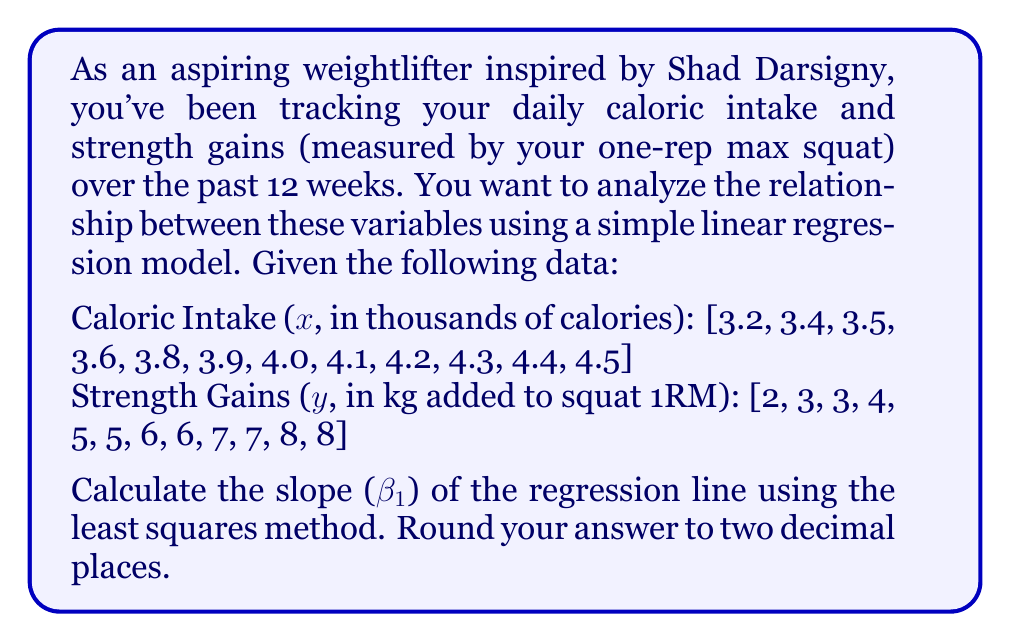What is the answer to this math problem? To calculate the slope (β₁) of the regression line using the least squares method, we'll use the formula:

$$ \beta_1 = \frac{n\sum{xy} - \sum{x}\sum{y}}{n\sum{x^2} - (\sum{x})^2} $$

Where:
n = number of data points
x = caloric intake (in thousands of calories)
y = strength gains (in kg added to squat 1RM)

Let's calculate each component:

1. n = 12 (12 weeks of data)

2. $\sum{x} = 47.9$
   $\sum{y} = 64$

3. $\sum{xy}$:
   $$(3.2 \times 2) + (3.4 \times 3) + ... + (4.5 \times 8) = 262.1$$

4. $\sum{x^2}$:
   $$(3.2^2) + (3.4^2) + ... + (4.5^2) = 192.91$$

5. $(\sum{x})^2 = 47.9^2 = 2294.41$

Now, let's substitute these values into the formula:

$$ \beta_1 = \frac{12(262.1) - (47.9)(64)}{12(192.91) - (2294.41)} $$

$$ \beta_1 = \frac{3145.2 - 3065.6}{2314.92 - 2294.41} $$

$$ \beta_1 = \frac{79.6}{20.51} $$

$$ \beta_1 \approx 3.88 $$

Rounding to two decimal places, we get 3.88.
Answer: 3.88 